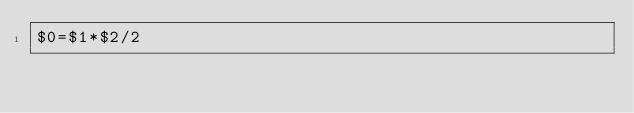<code> <loc_0><loc_0><loc_500><loc_500><_Awk_>$0=$1*$2/2</code> 